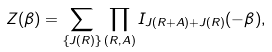Convert formula to latex. <formula><loc_0><loc_0><loc_500><loc_500>Z ( { \beta } ) = \sum _ { \{ J ( { R } ) \} } \prod _ { ( R , A ) } I _ { J ( { R + A } ) + J ( { R } ) } ( - \beta ) ,</formula> 